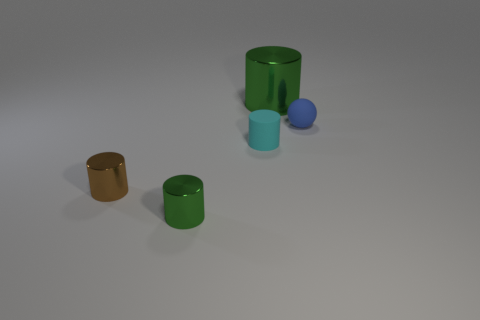Do the objects seem to be arranged in a pattern? The objects are not in a strict pattern, but they are arranged with what appears to be an intentional spacing on a plain surface - possibly hinting at a compositional study or a display with an aesthetic purpose. 